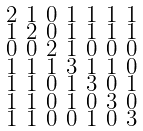<formula> <loc_0><loc_0><loc_500><loc_500>\begin{smallmatrix} 2 & 1 & 0 & 1 & 1 & 1 & 1 \\ 1 & 2 & 0 & 1 & 1 & 1 & 1 \\ 0 & 0 & 2 & 1 & 0 & 0 & 0 \\ 1 & 1 & 1 & 3 & 1 & 1 & 0 \\ 1 & 1 & 0 & 1 & 3 & 0 & 1 \\ 1 & 1 & 0 & 1 & 0 & 3 & 0 \\ 1 & 1 & 0 & 0 & 1 & 0 & 3 \end{smallmatrix}</formula> 